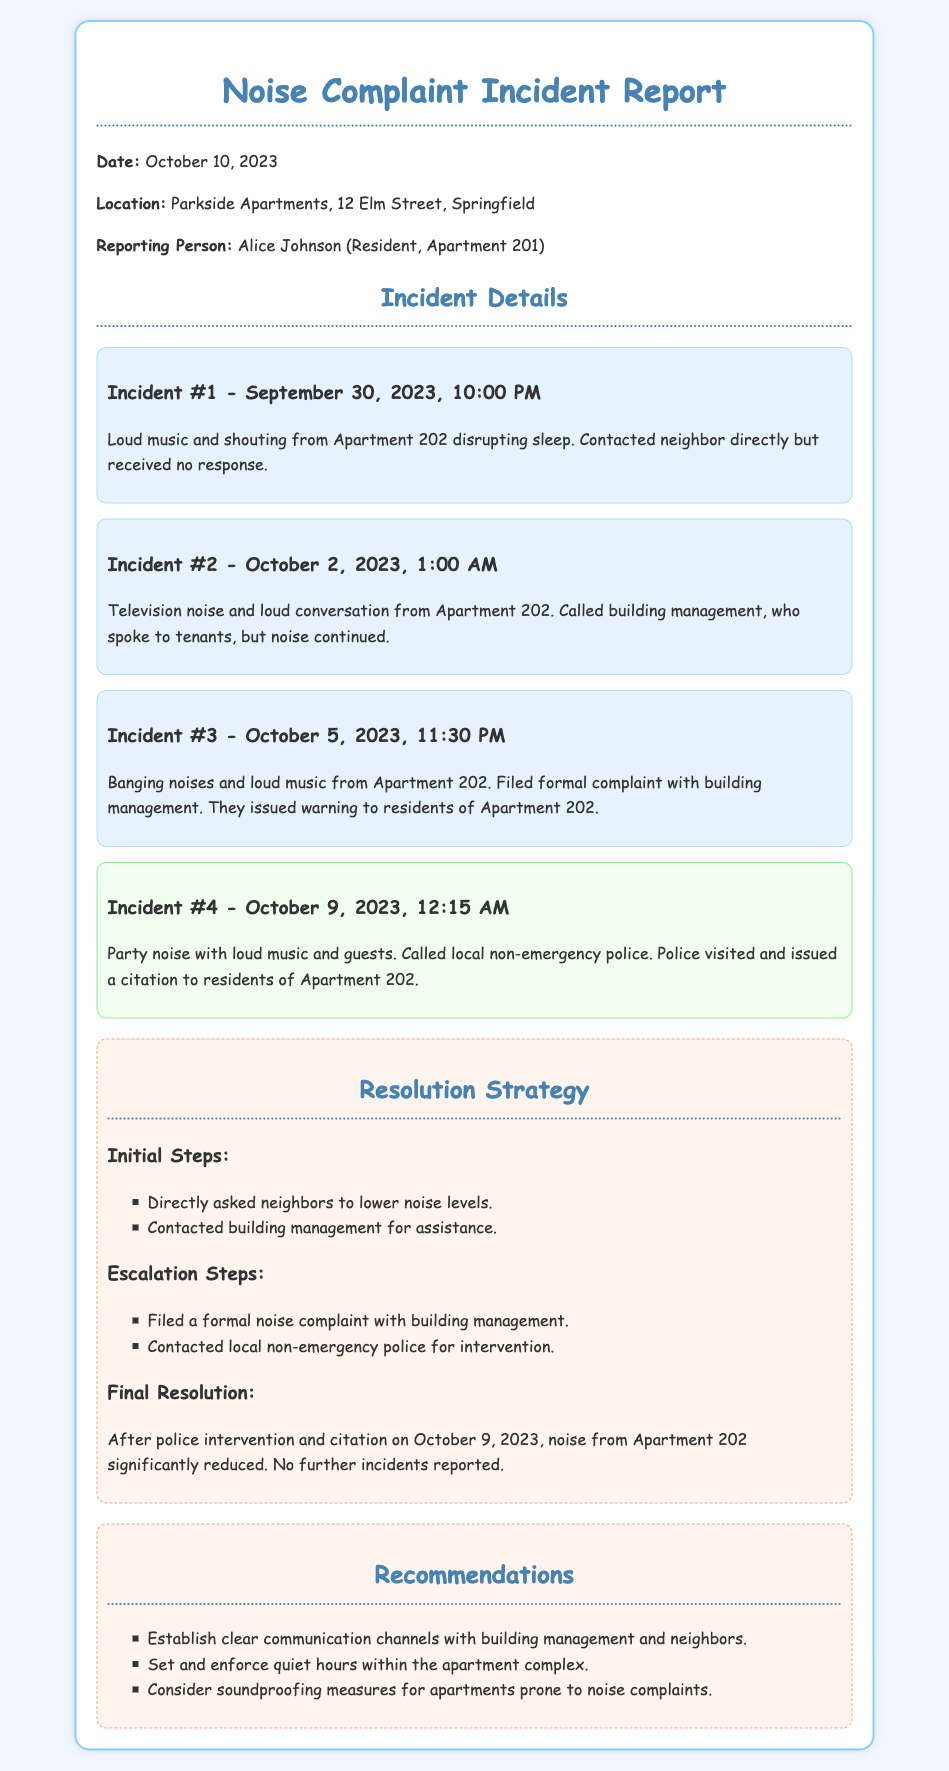What is the date of the incident report? The date of the incident report is mentioned in the document header.
Answer: October 10, 2023 Who is the reporting person? The reporting person's name is given under "Reporting Person" in the document.
Answer: Alice Johnson How many incidents were logged before police intervention? The document lists the incidents and notes the police intervention occurred after the fourth incident.
Answer: 3 What action was taken on October 9, 2023? This date corresponds to an incident involving police intervention as recorded in the complaints.
Answer: Issued a citation What were the initial steps taken to address the noise complaint? The initial steps can be found in the "Resolution Strategy" section under "Initial Steps".
Answer: Directly asked neighbors to lower noise levels What is categorized as the final resolution? The final resolution summarization can be found in the "Final Resolution" section of the strategy.
Answer: Noise from Apartment 202 significantly reduced Which apartment is the source of the complaints? The source of the complaints is mentioned throughout the incidents.
Answer: Apartment 202 What recommendations are made regarding communication? The recommendations outline how to improve communication channels, which are provided in the recommendations section.
Answer: Establish clear communication channels with building management and neighbors 